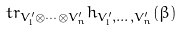Convert formula to latex. <formula><loc_0><loc_0><loc_500><loc_500>\ t r _ { V ^ { \prime } _ { 1 } \otimes \cdots \otimes V ^ { \prime } _ { n } } h _ { V ^ { \prime } _ { 1 } , \dots , V ^ { \prime } _ { n } } ( \beta )</formula> 